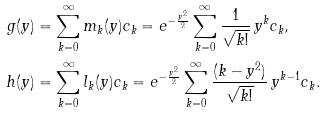<formula> <loc_0><loc_0><loc_500><loc_500>g ( y ) & = \sum _ { k = 0 } ^ { \infty } m _ { k } ( y ) c _ { k } = e ^ { - \frac { y ^ { 2 } } { 2 } } \sum _ { k = 0 } ^ { \infty } \frac { 1 } { \sqrt { k ! } } \, y ^ { k } c _ { k } , \\ h ( y ) & = \sum _ { k = 0 } ^ { \infty } l _ { k } ( y ) c _ { k } = e ^ { - \frac { y ^ { 2 } } { 2 } } \sum _ { k = 0 } ^ { \infty } \frac { ( k - y ^ { 2 } ) } { \sqrt { k ! } } \, y ^ { k - 1 } c _ { k } .</formula> 